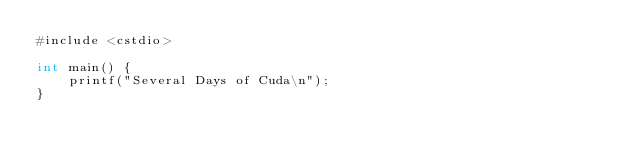Convert code to text. <code><loc_0><loc_0><loc_500><loc_500><_Cuda_>#include <cstdio>

int main() {
    printf("Several Days of Cuda\n");
}
</code> 